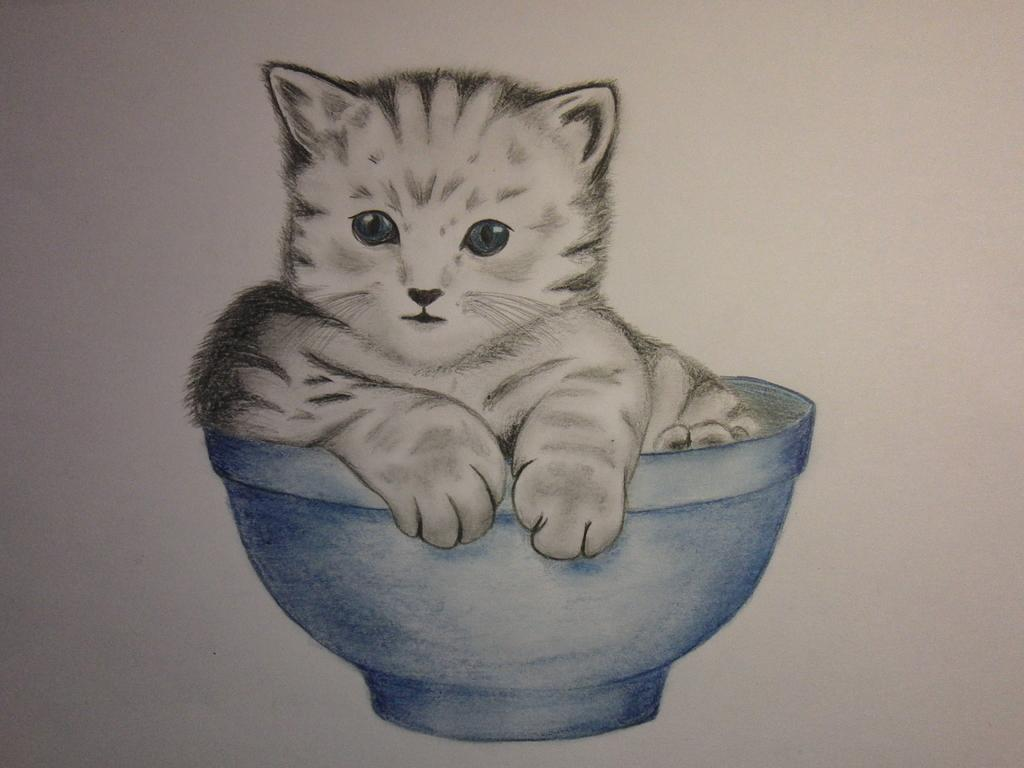What type of artwork is depicted in the image? The image is a painting. What animal can be seen in the painting? There is a cat in the painting. What is the cat sitting in? The cat is in a blue color bowl. How many stitches are used to create the cat's fur in the painting? The image is a painting, not a stitched piece of art, so there are no stitches used to create the cat's fur. 